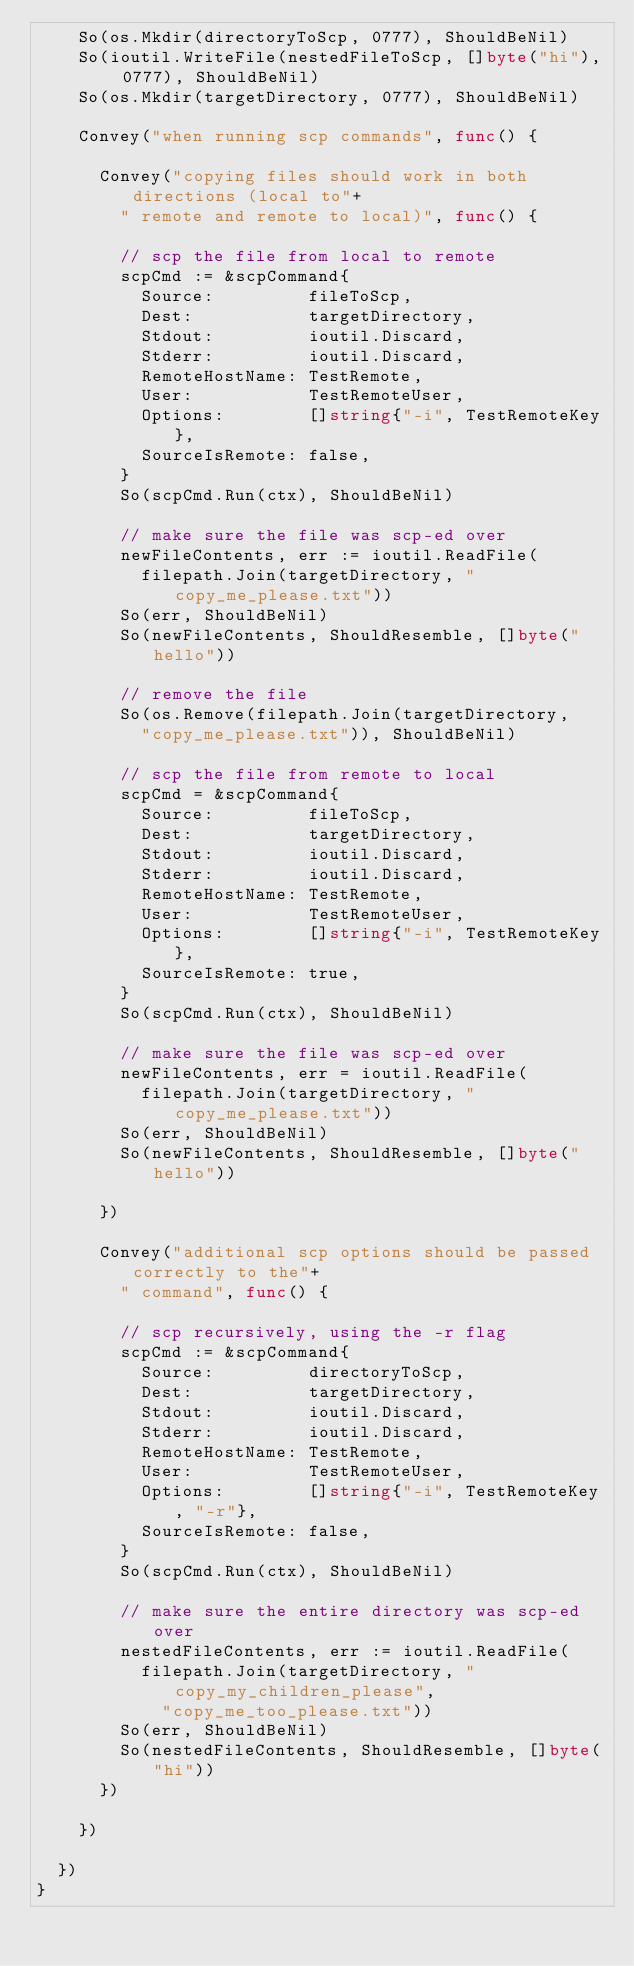<code> <loc_0><loc_0><loc_500><loc_500><_Go_>		So(os.Mkdir(directoryToScp, 0777), ShouldBeNil)
		So(ioutil.WriteFile(nestedFileToScp, []byte("hi"), 0777), ShouldBeNil)
		So(os.Mkdir(targetDirectory, 0777), ShouldBeNil)

		Convey("when running scp commands", func() {

			Convey("copying files should work in both directions (local to"+
				" remote and remote to local)", func() {

				// scp the file from local to remote
				scpCmd := &scpCommand{
					Source:         fileToScp,
					Dest:           targetDirectory,
					Stdout:         ioutil.Discard,
					Stderr:         ioutil.Discard,
					RemoteHostName: TestRemote,
					User:           TestRemoteUser,
					Options:        []string{"-i", TestRemoteKey},
					SourceIsRemote: false,
				}
				So(scpCmd.Run(ctx), ShouldBeNil)

				// make sure the file was scp-ed over
				newFileContents, err := ioutil.ReadFile(
					filepath.Join(targetDirectory, "copy_me_please.txt"))
				So(err, ShouldBeNil)
				So(newFileContents, ShouldResemble, []byte("hello"))

				// remove the file
				So(os.Remove(filepath.Join(targetDirectory,
					"copy_me_please.txt")), ShouldBeNil)

				// scp the file from remote to local
				scpCmd = &scpCommand{
					Source:         fileToScp,
					Dest:           targetDirectory,
					Stdout:         ioutil.Discard,
					Stderr:         ioutil.Discard,
					RemoteHostName: TestRemote,
					User:           TestRemoteUser,
					Options:        []string{"-i", TestRemoteKey},
					SourceIsRemote: true,
				}
				So(scpCmd.Run(ctx), ShouldBeNil)

				// make sure the file was scp-ed over
				newFileContents, err = ioutil.ReadFile(
					filepath.Join(targetDirectory, "copy_me_please.txt"))
				So(err, ShouldBeNil)
				So(newFileContents, ShouldResemble, []byte("hello"))

			})

			Convey("additional scp options should be passed correctly to the"+
				" command", func() {

				// scp recursively, using the -r flag
				scpCmd := &scpCommand{
					Source:         directoryToScp,
					Dest:           targetDirectory,
					Stdout:         ioutil.Discard,
					Stderr:         ioutil.Discard,
					RemoteHostName: TestRemote,
					User:           TestRemoteUser,
					Options:        []string{"-i", TestRemoteKey, "-r"},
					SourceIsRemote: false,
				}
				So(scpCmd.Run(ctx), ShouldBeNil)

				// make sure the entire directory was scp-ed over
				nestedFileContents, err := ioutil.ReadFile(
					filepath.Join(targetDirectory, "copy_my_children_please",
						"copy_me_too_please.txt"))
				So(err, ShouldBeNil)
				So(nestedFileContents, ShouldResemble, []byte("hi"))
			})

		})

	})
}
</code> 